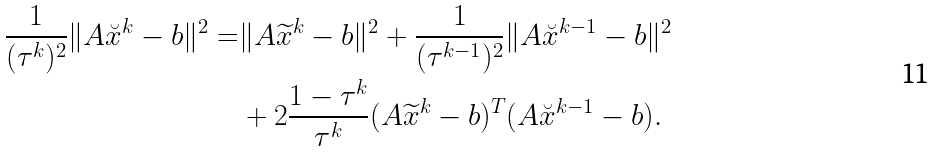Convert formula to latex. <formula><loc_0><loc_0><loc_500><loc_500>\frac { 1 } { ( \tau ^ { k } ) ^ { 2 } } \| A \breve { x } ^ { k } - b \| ^ { 2 } = & \| A \widetilde { x } ^ { k } - b \| ^ { 2 } + \frac { 1 } { ( \tau ^ { k - 1 } ) ^ { 2 } } \| A \breve { x } ^ { k - 1 } - b \| ^ { 2 } \\ & + 2 \frac { 1 - \tau ^ { k } } { \tau ^ { k } } ( A \widetilde { x } ^ { k } - b ) ^ { T } ( A \breve { x } ^ { k - 1 } - b ) .</formula> 